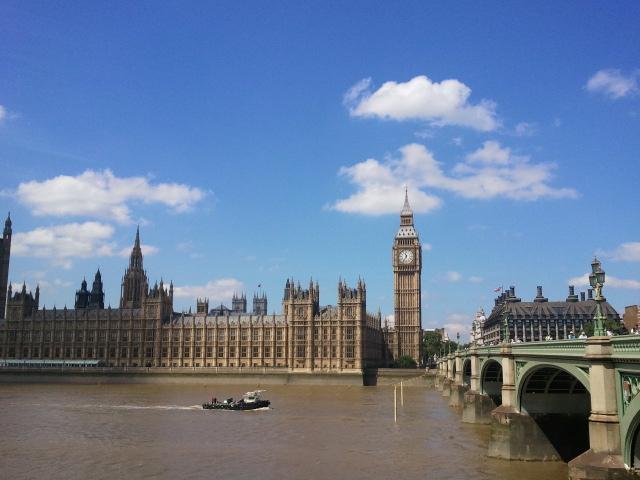How many books on the hand are there?
Give a very brief answer. 0. 